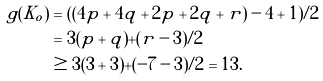Convert formula to latex. <formula><loc_0><loc_0><loc_500><loc_500>g ( K _ { o } ) & = ( \left ( 4 p + 4 q + 2 p + 2 q + r \right ) - 4 + 1 ) / 2 \\ & = 3 ( p + q ) + ( r - 3 ) / 2 \\ & \geq 3 ( 3 + 3 ) + ( - 7 - 3 ) / 2 = 1 3 .</formula> 